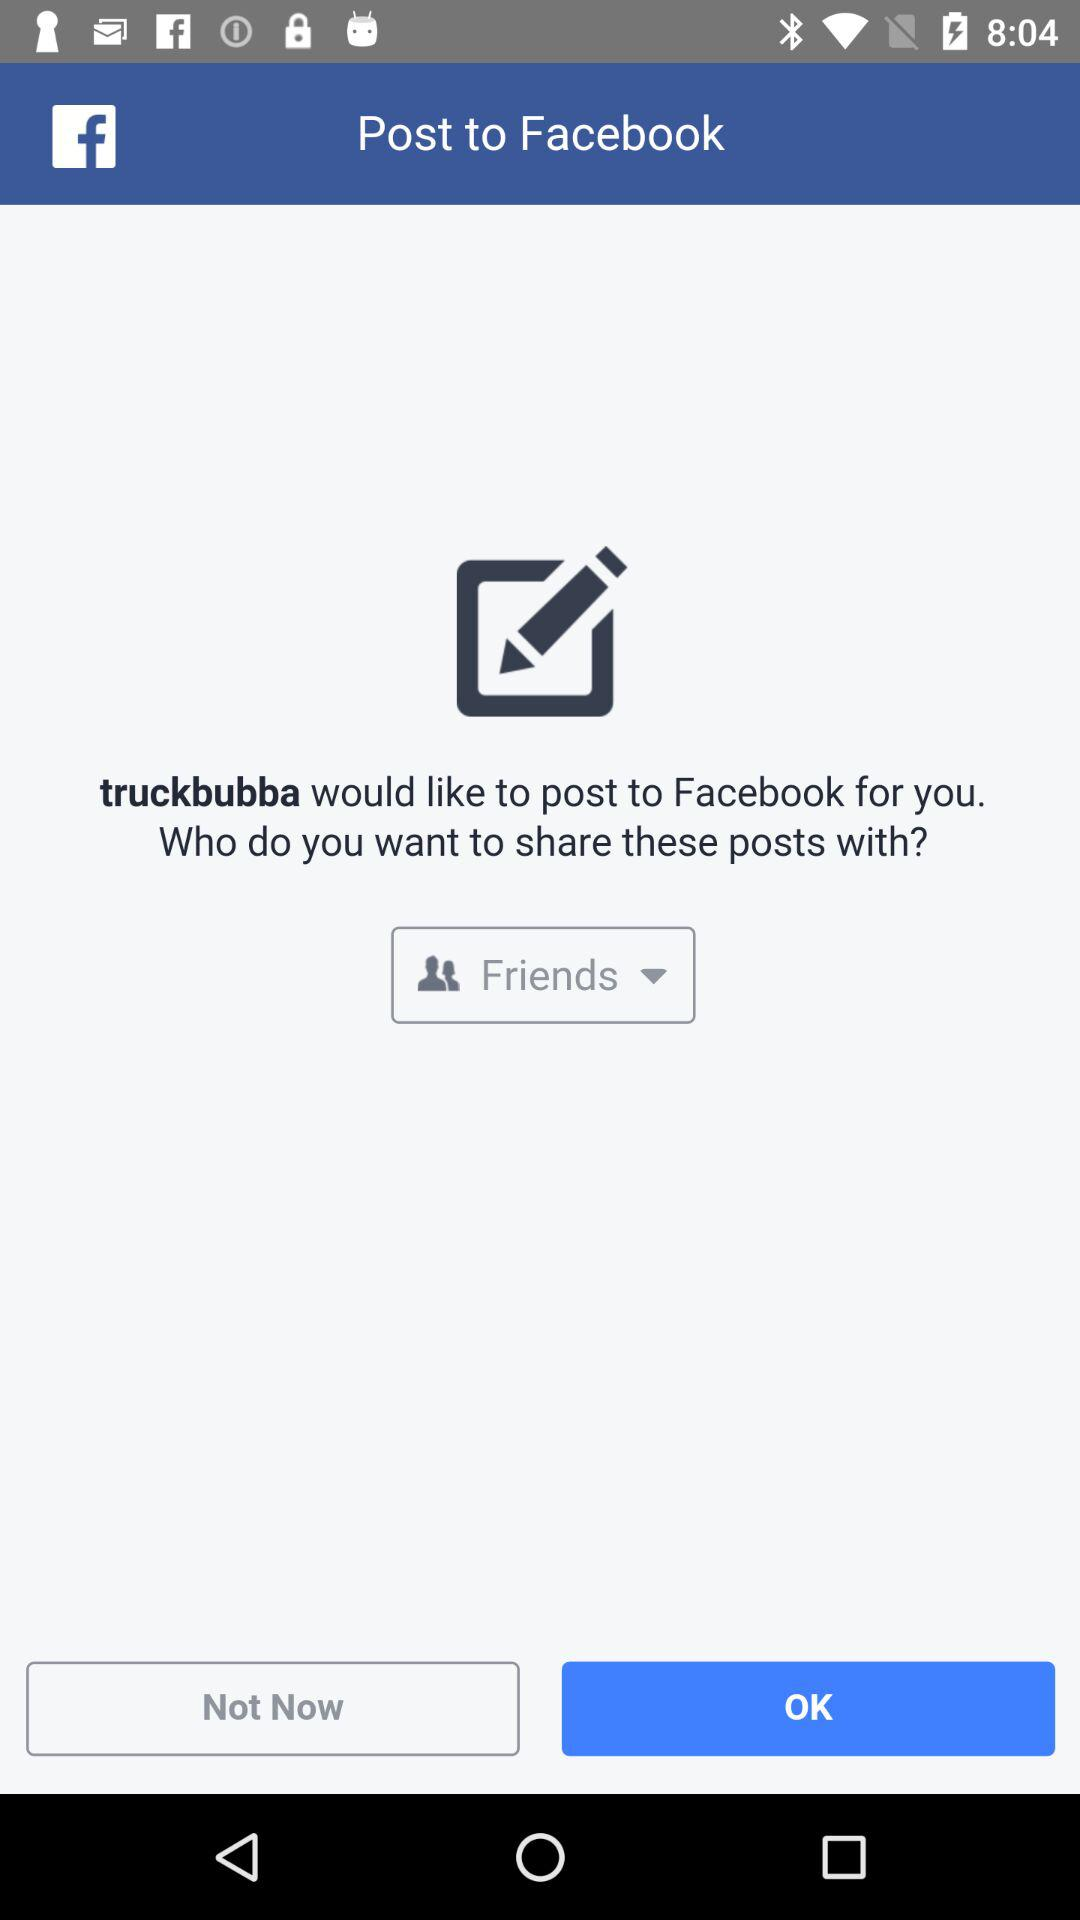Which option is selected in the drop-down box? The selected option is "Friends". 